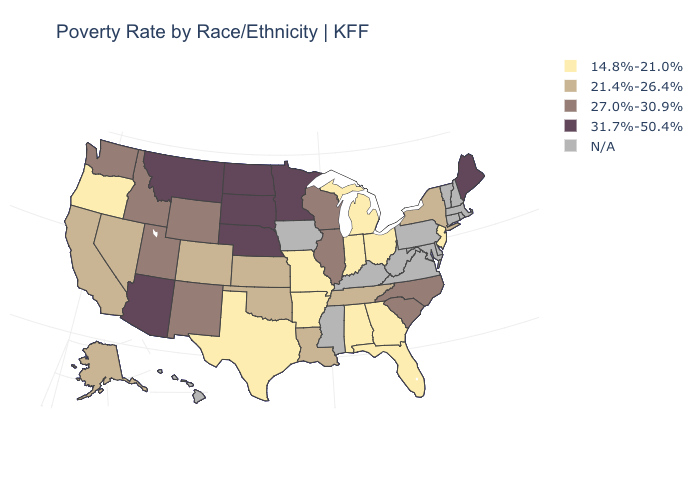What is the value of Hawaii?
Give a very brief answer. N/A. Name the states that have a value in the range N/A?
Short answer required. Connecticut, Delaware, Hawaii, Iowa, Kentucky, Maryland, Massachusetts, Mississippi, New Hampshire, Pennsylvania, Rhode Island, Vermont, Virginia, West Virginia. Among the states that border Pennsylvania , which have the lowest value?
Give a very brief answer. New Jersey, Ohio. What is the highest value in the USA?
Concise answer only. 31.7%-50.4%. Which states have the highest value in the USA?
Keep it brief. Arizona, Maine, Minnesota, Montana, Nebraska, North Dakota, South Dakota. Name the states that have a value in the range 27.0%-30.9%?
Quick response, please. Idaho, Illinois, New Mexico, North Carolina, South Carolina, Utah, Washington, Wisconsin, Wyoming. What is the value of Wyoming?
Answer briefly. 27.0%-30.9%. What is the value of Tennessee?
Quick response, please. 21.4%-26.4%. Does Louisiana have the lowest value in the South?
Write a very short answer. No. Which states have the lowest value in the USA?
Quick response, please. Alabama, Arkansas, Florida, Georgia, Indiana, Michigan, Missouri, New Jersey, Ohio, Oregon, Texas. Does New York have the lowest value in the Northeast?
Give a very brief answer. No. Does Colorado have the lowest value in the USA?
Keep it brief. No. Is the legend a continuous bar?
Short answer required. No. 